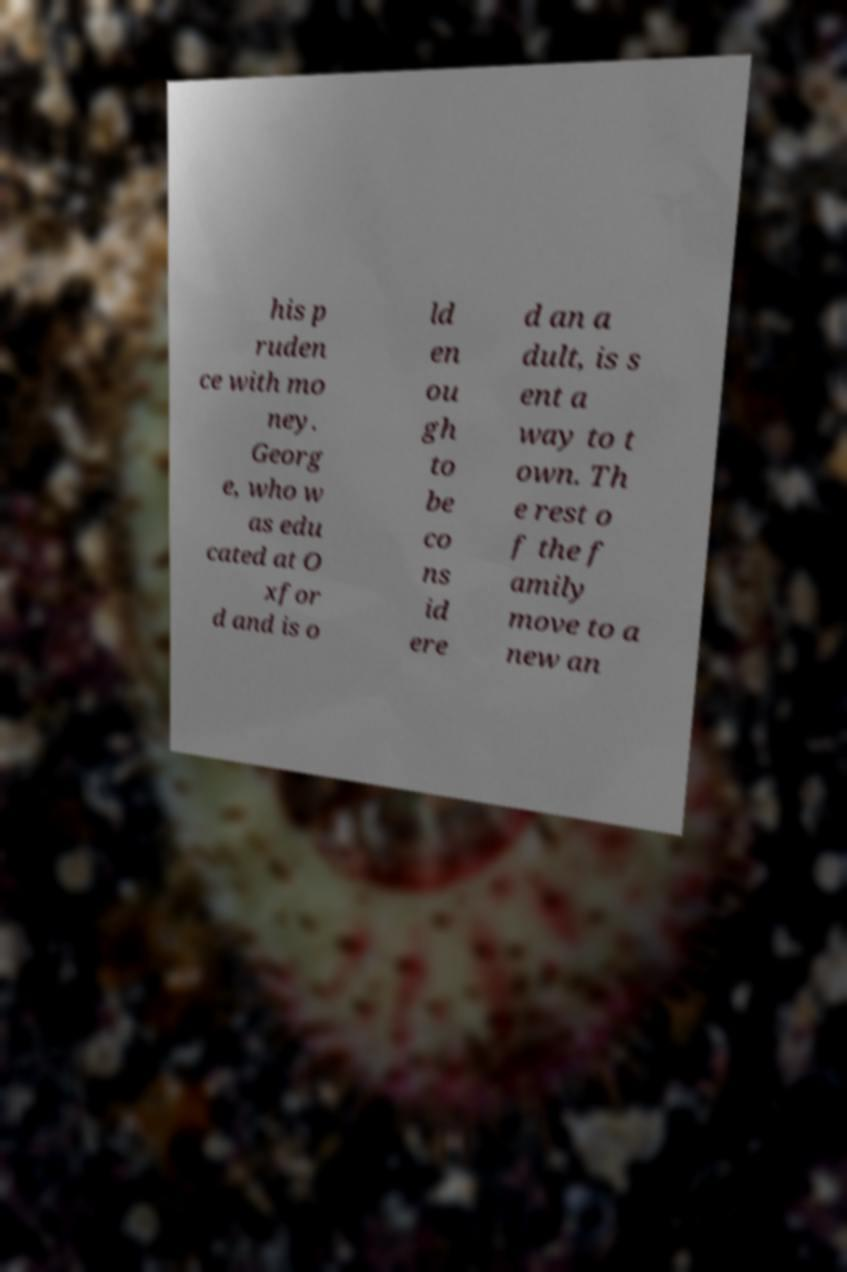Please read and relay the text visible in this image. What does it say? his p ruden ce with mo ney. Georg e, who w as edu cated at O xfor d and is o ld en ou gh to be co ns id ere d an a dult, is s ent a way to t own. Th e rest o f the f amily move to a new an 